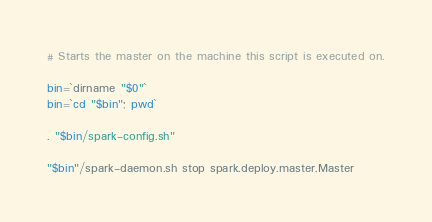Convert code to text. <code><loc_0><loc_0><loc_500><loc_500><_Bash_>
# Starts the master on the machine this script is executed on.

bin=`dirname "$0"`
bin=`cd "$bin"; pwd`

. "$bin/spark-config.sh"

"$bin"/spark-daemon.sh stop spark.deploy.master.Master</code> 